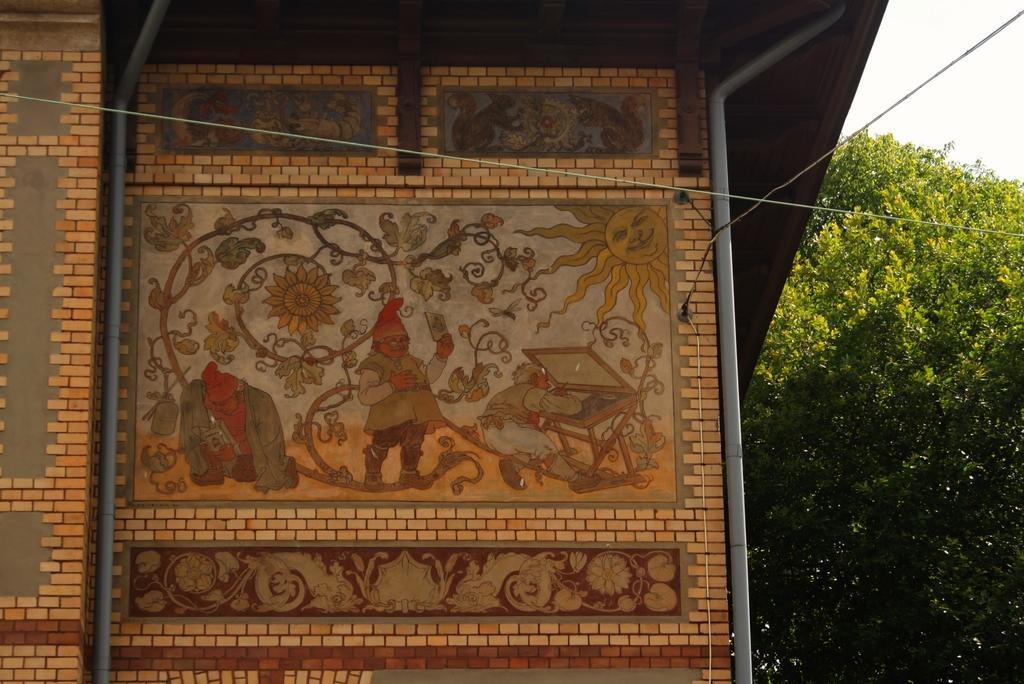Can you describe this image briefly? In the picture we can see a house wall with some arts and paintings on it and beside it, we can see a tree and a part of the sky. 